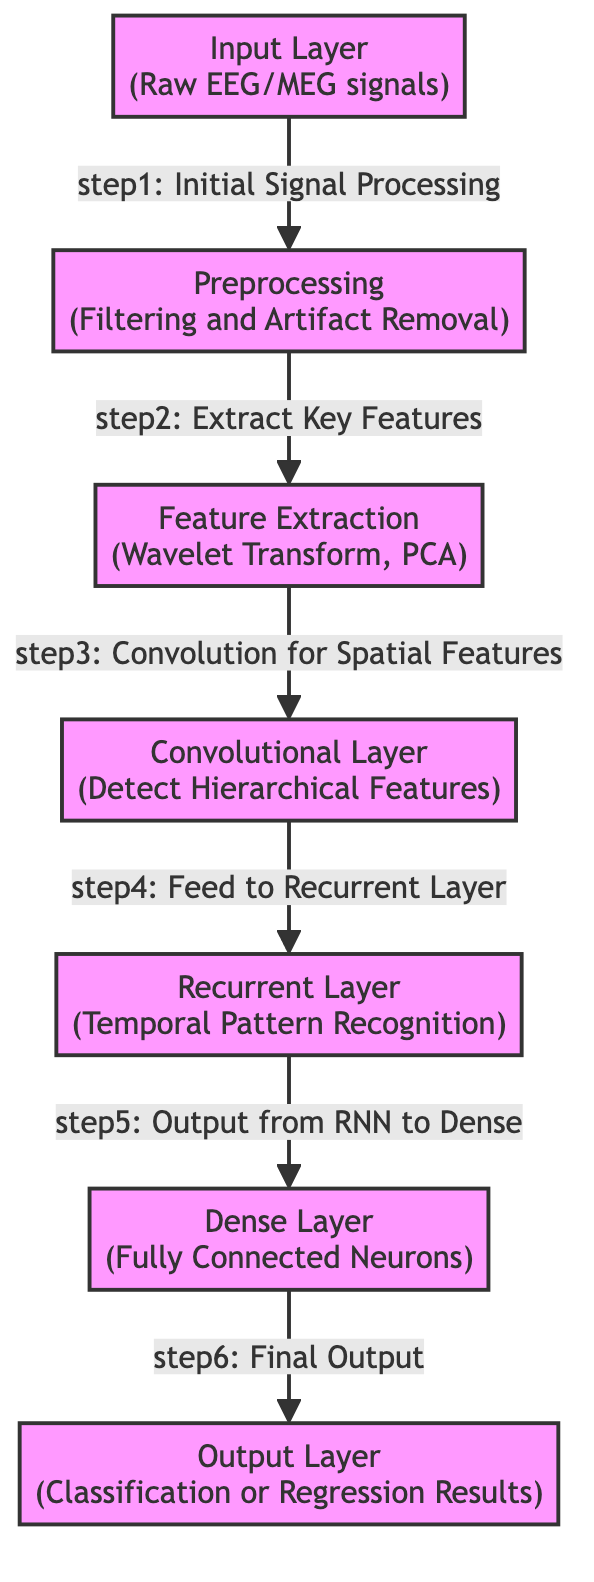What type of signals does the Input Layer process? The Input Layer processes "Raw EEG/MEG signals," as specified in the diagram. This is indicated directly in the label of the Input Layer node.
Answer: Raw EEG/MEG signals How many layers are there in total? The diagram contains seven distinct layers: Input Layer, Preprocessing, Feature Extraction, CNN Layer, RNN Layer, Dense Layer, and Output Layer. Counted directly from the nodes.
Answer: 7 What is the first step in the signal processing flow? The first step in the processing flow is indicated as "Initial Signal Processing," which comes after the Input Layer. It connects to the Preprocessing layer.
Answer: Initial Signal Processing Which layer performs temporal pattern recognition? The layer responsible for temporal pattern recognition is the RNN Layer, as stated in its label in the diagram.
Answer: RNN Layer What is the final output of the network referred to in the Output Layer? The final output is noted as "Classification or Regression Results," which summarizes the types of outputs produced by the preceding layers.
Answer: Classification or Regression Results What connects the CNN Layer to the RNN Layer? The connection from the CNN Layer to the RNN Layer is described as "Feed to Recurrent Layer," indicating how features are passed along in the processing.
Answer: Feed to Recurrent Layer Which layer is responsible for filtering and artifact removal? The Preprocessing layer is specifically responsible for filtering and artifact removal in the signal processing as indicated in its label.
Answer: Preprocessing What does the Dense Layer consist of? The Dense Layer is described as consisting of "Fully Connected Neurons," indicating its structure and function within the neural network architecture.
Answer: Fully Connected Neurons What type of features does the Feature Extraction node focus on? The Feature Extraction node focuses on "Wavelet Transform, PCA," which are specific methods for extracting key features from the processed signals.
Answer: Wavelet Transform, PCA 